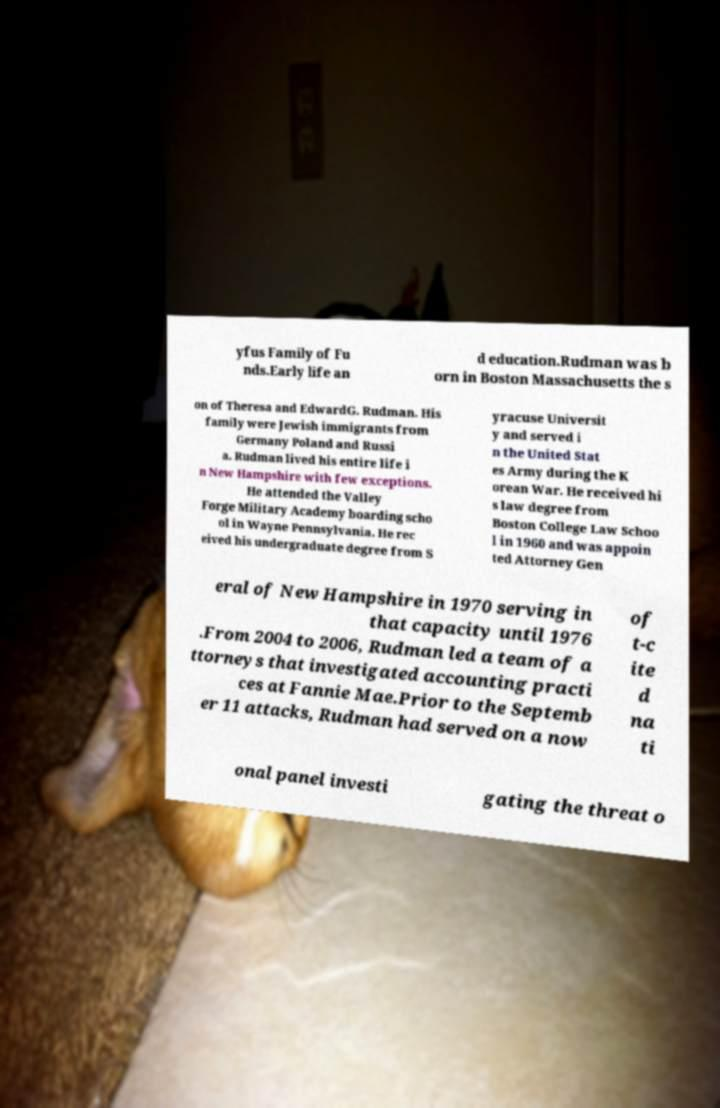What messages or text are displayed in this image? I need them in a readable, typed format. yfus Family of Fu nds.Early life an d education.Rudman was b orn in Boston Massachusetts the s on of Theresa and EdwardG. Rudman. His family were Jewish immigrants from Germany Poland and Russi a. Rudman lived his entire life i n New Hampshire with few exceptions. He attended the Valley Forge Military Academy boarding scho ol in Wayne Pennsylvania. He rec eived his undergraduate degree from S yracuse Universit y and served i n the United Stat es Army during the K orean War. He received hi s law degree from Boston College Law Schoo l in 1960 and was appoin ted Attorney Gen eral of New Hampshire in 1970 serving in that capacity until 1976 .From 2004 to 2006, Rudman led a team of a ttorneys that investigated accounting practi ces at Fannie Mae.Prior to the Septemb er 11 attacks, Rudman had served on a now of t-c ite d na ti onal panel investi gating the threat o 